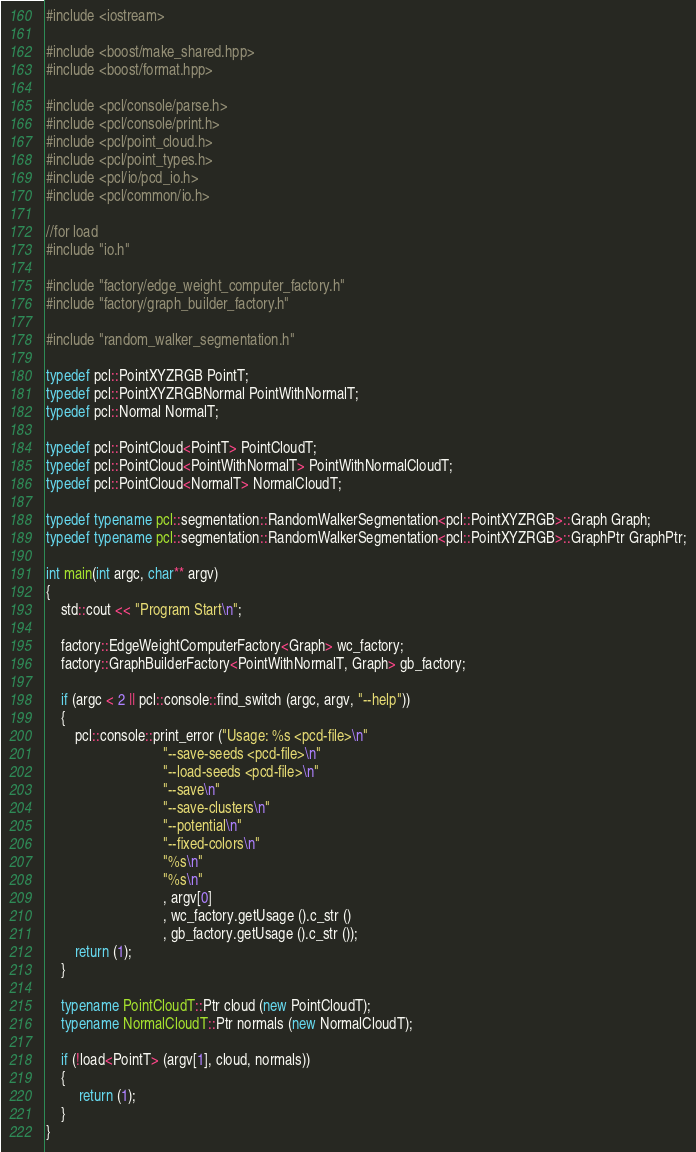Convert code to text. <code><loc_0><loc_0><loc_500><loc_500><_C++_>#include <iostream>

#include <boost/make_shared.hpp>
#include <boost/format.hpp>

#include <pcl/console/parse.h>
#include <pcl/console/print.h>
#include <pcl/point_cloud.h>
#include <pcl/point_types.h>
#include <pcl/io/pcd_io.h>
#include <pcl/common/io.h>

//for load 
#include "io.h"

#include "factory/edge_weight_computer_factory.h"
#include "factory/graph_builder_factory.h"

#include "random_walker_segmentation.h"

typedef pcl::PointXYZRGB PointT;
typedef pcl::PointXYZRGBNormal PointWithNormalT;
typedef pcl::Normal NormalT;

typedef pcl::PointCloud<PointT> PointCloudT;
typedef pcl::PointCloud<PointWithNormalT> PointWithNormalCloudT;
typedef pcl::PointCloud<NormalT> NormalCloudT;

typedef typename pcl::segmentation::RandomWalkerSegmentation<pcl::PointXYZRGB>::Graph Graph;
typedef typename pcl::segmentation::RandomWalkerSegmentation<pcl::PointXYZRGB>::GraphPtr GraphPtr;

int main(int argc, char** argv) 
{
    std::cout << "Program Start\n";

    factory::EdgeWeightComputerFactory<Graph> wc_factory;
    factory::GraphBuilderFactory<PointWithNormalT, Graph> gb_factory;

    if (argc < 2 || pcl::console::find_switch (argc, argv, "--help"))
    {
        pcl::console::print_error ("Usage: %s <pcd-file>\n"
                                "--save-seeds <pcd-file>\n"
                                "--load-seeds <pcd-file>\n"
                                "--save\n"
                                "--save-clusters\n"
                                "--potential\n"
                                "--fixed-colors\n"
                                "%s\n"
                                "%s\n"
                                , argv[0]
                                , wc_factory.getUsage ().c_str ()
                                , gb_factory.getUsage ().c_str ());
        return (1);
    }

    typename PointCloudT::Ptr cloud (new PointCloudT);
    typename NormalCloudT::Ptr normals (new NormalCloudT);

    if (!load<PointT> (argv[1], cloud, normals))
    {
         return (1);
    }
}
</code> 